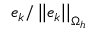Convert formula to latex. <formula><loc_0><loc_0><loc_500><loc_500>e _ { k } / \left | \left | e _ { k } \right | \right | _ { \Omega _ { h } }</formula> 